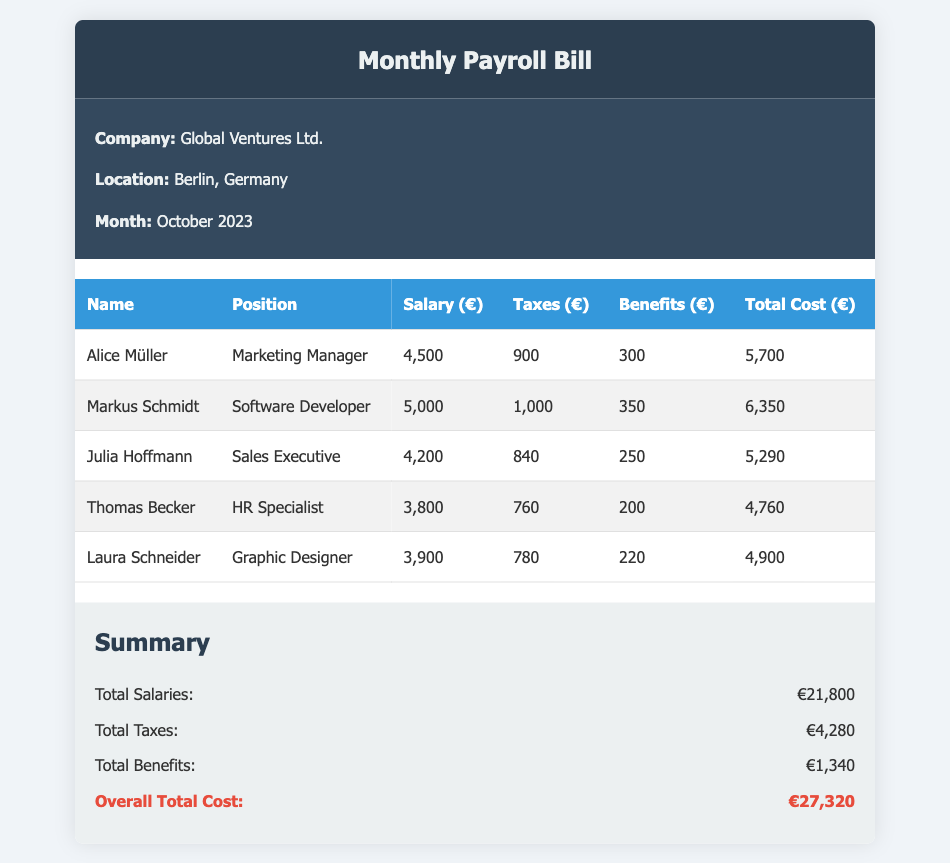What is the company name? The company name is provided at the top of the document.
Answer: Global Ventures Ltd Which position does Alice Müller hold? The position of Alice Müller is listed in the employee details section.
Answer: Marketing Manager What is the total cost for Markus Schmidt? The total cost can be derived from the corresponding row in the payroll table.
Answer: 6,350 How much are the total taxes? The total taxes are found in the summary section of the document.
Answer: 4,280 What is Laura Schneider's salary? Laura Schneider's salary is displayed in the payroll table among the employee details.
Answer: 3,900 What is the overall total cost? The overall total cost is calculated from the summary section of the document.
Answer: 27,320 How many employees are listed? The number of employees can be counted from the rows in the payroll table.
Answer: 5 What benefits does Julia Hoffmann receive? Julia Hoffmann's benefits are shown in the payroll table corresponding to her record.
Answer: 250 What is the average salary of the listed employees? The average salary is calculated from the total salaries divided by the number of employees.
Answer: 4,360 